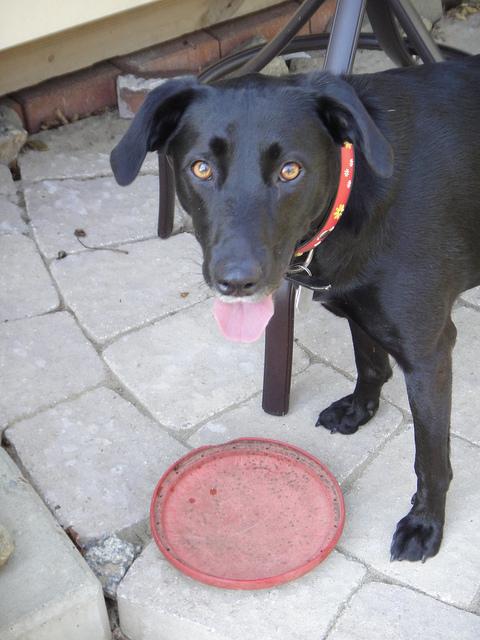Why is there nothing on the plate?
Keep it brief. Dog ate it. Is the dog wearing a collar?
Concise answer only. Yes. Is the dog thirsty?
Concise answer only. Yes. Where is the pet dish?
Be succinct. Ground. What is the dog doing?
Keep it brief. Panting. 